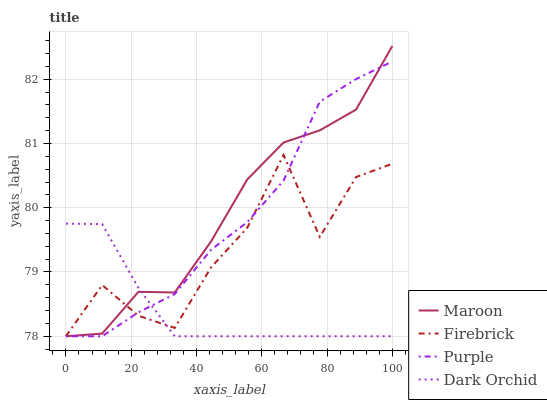Does Dark Orchid have the minimum area under the curve?
Answer yes or no. Yes. Does Maroon have the maximum area under the curve?
Answer yes or no. Yes. Does Firebrick have the minimum area under the curve?
Answer yes or no. No. Does Firebrick have the maximum area under the curve?
Answer yes or no. No. Is Dark Orchid the smoothest?
Answer yes or no. Yes. Is Firebrick the roughest?
Answer yes or no. Yes. Is Firebrick the smoothest?
Answer yes or no. No. Is Dark Orchid the roughest?
Answer yes or no. No. Does Purple have the lowest value?
Answer yes or no. Yes. Does Maroon have the highest value?
Answer yes or no. Yes. Does Firebrick have the highest value?
Answer yes or no. No. Does Maroon intersect Purple?
Answer yes or no. Yes. Is Maroon less than Purple?
Answer yes or no. No. Is Maroon greater than Purple?
Answer yes or no. No. 